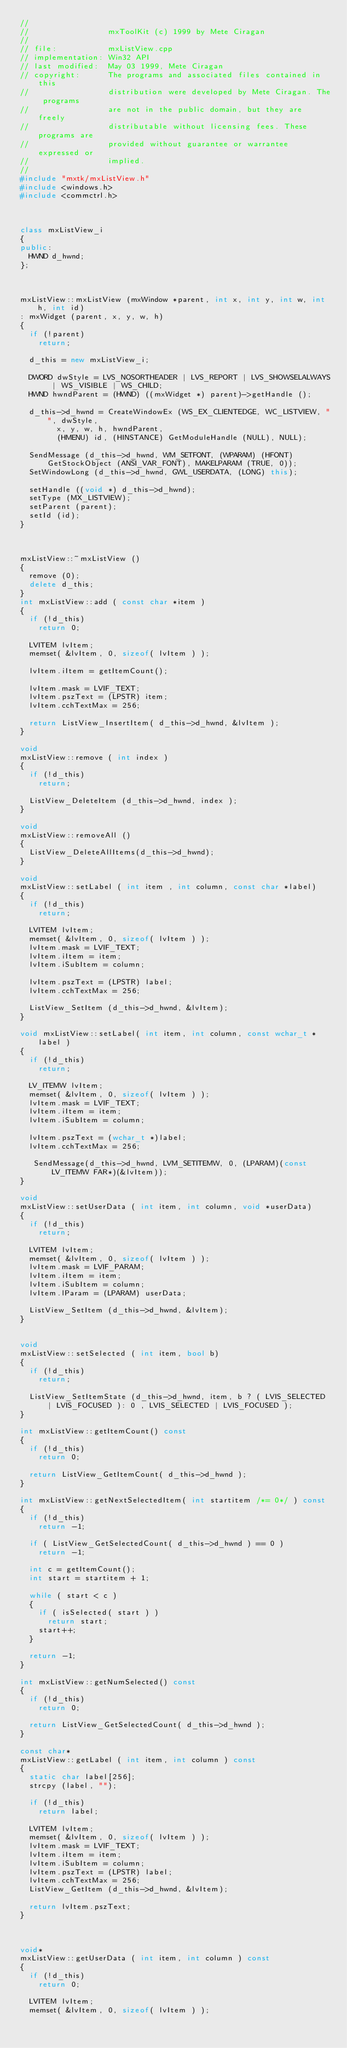<code> <loc_0><loc_0><loc_500><loc_500><_C++_>//
//                 mxToolKit (c) 1999 by Mete Ciragan
//
// file:           mxListView.cpp
// implementation: Win32 API
// last modified:  May 03 1999, Mete Ciragan
// copyright:      The programs and associated files contained in this
//                 distribution were developed by Mete Ciragan. The programs
//                 are not in the public domain, but they are freely
//                 distributable without licensing fees. These programs are
//                 provided without guarantee or warrantee expressed or
//                 implied.
//
#include "mxtk/mxListView.h"
#include <windows.h>
#include <commctrl.h>



class mxListView_i
{
public:
	HWND d_hwnd;
};



mxListView::mxListView (mxWindow *parent, int x, int y, int w, int h, int id)
: mxWidget (parent, x, y, w, h)
{
	if (!parent)
		return;

	d_this = new mxListView_i;

	DWORD dwStyle = LVS_NOSORTHEADER | LVS_REPORT | LVS_SHOWSELALWAYS | WS_VISIBLE | WS_CHILD;
	HWND hwndParent = (HWND) ((mxWidget *) parent)->getHandle ();

	d_this->d_hwnd = CreateWindowEx (WS_EX_CLIENTEDGE, WC_LISTVIEW, "", dwStyle,
				x, y, w, h, hwndParent,
				(HMENU) id, (HINSTANCE) GetModuleHandle (NULL), NULL);
	
	SendMessage (d_this->d_hwnd, WM_SETFONT, (WPARAM) (HFONT) GetStockObject (ANSI_VAR_FONT), MAKELPARAM (TRUE, 0));
	SetWindowLong (d_this->d_hwnd, GWL_USERDATA, (LONG) this);

	setHandle ((void *) d_this->d_hwnd);
	setType (MX_LISTVIEW);
	setParent (parent);
	setId (id);
}



mxListView::~mxListView ()
{
	remove (0);
	delete d_this;
}
int mxListView::add ( const char *item )
{
	if (!d_this)
		return 0;

	LVITEM lvItem;
	memset( &lvItem, 0, sizeof( lvItem ) );

	lvItem.iItem = getItemCount();

	lvItem.mask = LVIF_TEXT;
	lvItem.pszText = (LPSTR) item;
	lvItem.cchTextMax = 256;

	return ListView_InsertItem( d_this->d_hwnd, &lvItem );
}

void
mxListView::remove ( int index )
{
	if (!d_this)
		return;

	ListView_DeleteItem (d_this->d_hwnd, index );
}

void
mxListView::removeAll ()
{
	ListView_DeleteAllItems(d_this->d_hwnd);
}

void
mxListView::setLabel ( int item , int column, const char *label)
{
	if (!d_this)
		return;

	LVITEM lvItem;
	memset( &lvItem, 0, sizeof( lvItem ) );
	lvItem.mask = LVIF_TEXT;
	lvItem.iItem = item;
	lvItem.iSubItem = column;

	lvItem.pszText = (LPSTR) label;
	lvItem.cchTextMax = 256;

	ListView_SetItem (d_this->d_hwnd, &lvItem);
}

void mxListView::setLabel( int item, int column, const wchar_t *label )
{
	if (!d_this)
		return;

	LV_ITEMW lvItem;
	memset( &lvItem, 0, sizeof( lvItem ) );
	lvItem.mask = LVIF_TEXT;
	lvItem.iItem = item;
	lvItem.iSubItem = column;

	lvItem.pszText = (wchar_t *)label;
	lvItem.cchTextMax = 256;

   SendMessage(d_this->d_hwnd, LVM_SETITEMW, 0, (LPARAM)(const LV_ITEMW FAR*)(&lvItem));
}

void
mxListView::setUserData ( int item, int column, void *userData)
{
	if (!d_this)
		return;

	LVITEM lvItem;
	memset( &lvItem, 0, sizeof( lvItem ) );
	lvItem.mask = LVIF_PARAM;
	lvItem.iItem = item;
	lvItem.iSubItem = column;
	lvItem.lParam = (LPARAM) userData;

	ListView_SetItem (d_this->d_hwnd, &lvItem);
}


void
mxListView::setSelected ( int item, bool b)
{
	if (!d_this)
		return;

	ListView_SetItemState (d_this->d_hwnd, item, b ? ( LVIS_SELECTED | LVIS_FOCUSED ): 0 , LVIS_SELECTED | LVIS_FOCUSED );
}

int mxListView::getItemCount() const
{
	if (!d_this)
		return 0;

	return ListView_GetItemCount( d_this->d_hwnd );
}

int mxListView::getNextSelectedItem( int startitem /*= 0*/ ) const
{
	if (!d_this)
		return -1;

	if ( ListView_GetSelectedCount( d_this->d_hwnd ) == 0 )
		return -1;

	int c = getItemCount();
	int start = startitem + 1;

	while ( start < c )
	{
		if ( isSelected( start ) )
			return start;
		start++;
	}

	return -1;
}

int mxListView::getNumSelected() const
{
	if (!d_this)
		return 0;

	return ListView_GetSelectedCount( d_this->d_hwnd );
}

const char*
mxListView::getLabel ( int item, int column ) const
{
	static char label[256];
	strcpy (label, "");

	if (!d_this)
		return label;

	LVITEM lvItem;
	memset( &lvItem, 0, sizeof( lvItem ) );
	lvItem.mask = LVIF_TEXT;
	lvItem.iItem = item;
	lvItem.iSubItem = column;
	lvItem.pszText = (LPSTR) label;
	lvItem.cchTextMax = 256;
	ListView_GetItem (d_this->d_hwnd, &lvItem);

	return lvItem.pszText;
}



void*
mxListView::getUserData ( int item, int column ) const
{
	if (!d_this)
		return 0;

	LVITEM lvItem;
	memset( &lvItem, 0, sizeof( lvItem ) );</code> 